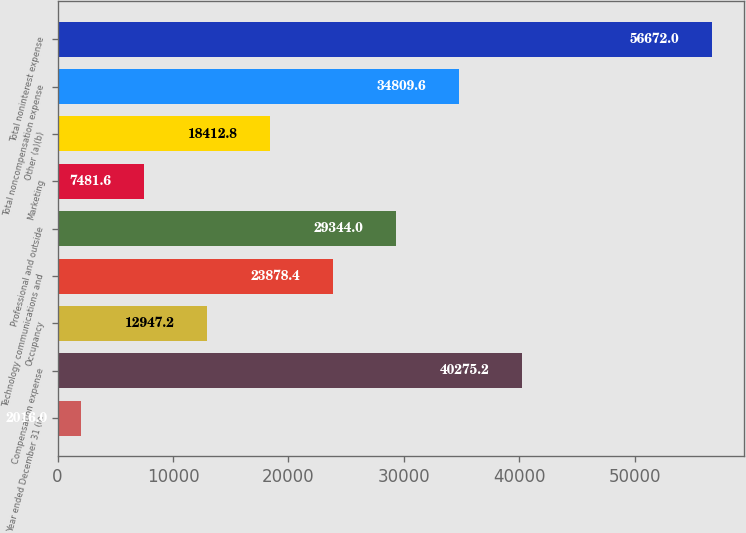<chart> <loc_0><loc_0><loc_500><loc_500><bar_chart><fcel>Year ended December 31 (in<fcel>Compensation expense<fcel>Occupancy<fcel>Technology communications and<fcel>Professional and outside<fcel>Marketing<fcel>Other (a)(b)<fcel>Total noncompensation expense<fcel>Total noninterest expense<nl><fcel>2016<fcel>40275.2<fcel>12947.2<fcel>23878.4<fcel>29344<fcel>7481.6<fcel>18412.8<fcel>34809.6<fcel>56672<nl></chart> 